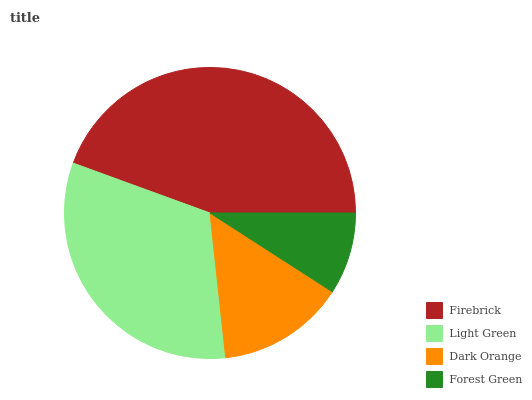Is Forest Green the minimum?
Answer yes or no. Yes. Is Firebrick the maximum?
Answer yes or no. Yes. Is Light Green the minimum?
Answer yes or no. No. Is Light Green the maximum?
Answer yes or no. No. Is Firebrick greater than Light Green?
Answer yes or no. Yes. Is Light Green less than Firebrick?
Answer yes or no. Yes. Is Light Green greater than Firebrick?
Answer yes or no. No. Is Firebrick less than Light Green?
Answer yes or no. No. Is Light Green the high median?
Answer yes or no. Yes. Is Dark Orange the low median?
Answer yes or no. Yes. Is Forest Green the high median?
Answer yes or no. No. Is Firebrick the low median?
Answer yes or no. No. 